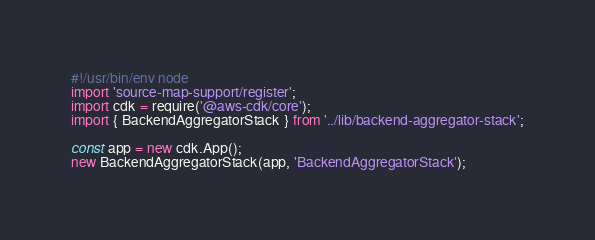<code> <loc_0><loc_0><loc_500><loc_500><_TypeScript_>#!/usr/bin/env node
import 'source-map-support/register';
import cdk = require('@aws-cdk/core');
import { BackendAggregatorStack } from '../lib/backend-aggregator-stack';

const app = new cdk.App();
new BackendAggregatorStack(app, 'BackendAggregatorStack');
</code> 